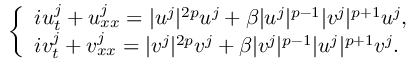<formula> <loc_0><loc_0><loc_500><loc_500>\begin{array} { r } { \left \{ \begin{array} { l } { i u _ { t } ^ { j } + u _ { x x } ^ { j } = | u ^ { j } | ^ { 2 p } u ^ { j } + \beta | u ^ { j } | ^ { p - 1 } | v ^ { j } | ^ { p + 1 } u ^ { j } , } \\ { i v _ { t } ^ { j } + v _ { x x } ^ { j } = | v ^ { j } | ^ { 2 p } v ^ { j } + \beta | v ^ { j } | ^ { p - 1 } | u ^ { j } | ^ { p + 1 } v ^ { j } . } \end{array} } \end{array}</formula> 